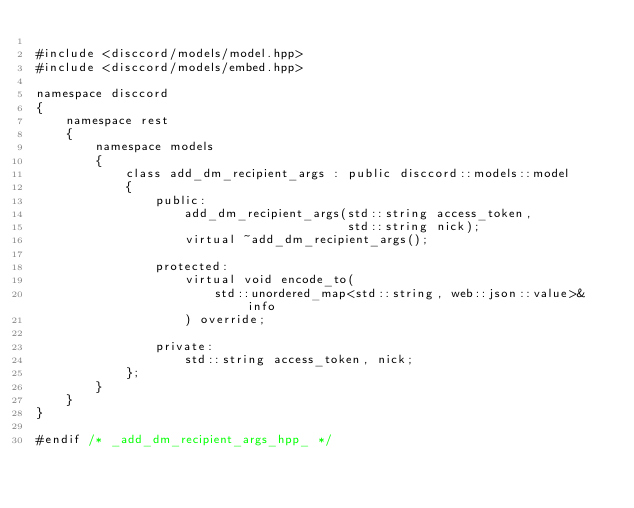<code> <loc_0><loc_0><loc_500><loc_500><_C++_>
#include <disccord/models/model.hpp>
#include <disccord/models/embed.hpp>

namespace disccord
{
    namespace rest
    {
        namespace models
        {
            class add_dm_recipient_args : public disccord::models::model
            {
                public:
                    add_dm_recipient_args(std::string access_token,
                                          std::string nick);
                    virtual ~add_dm_recipient_args();

                protected:
                    virtual void encode_to(
                        std::unordered_map<std::string, web::json::value>& info
                    ) override;

                private:
                    std::string access_token, nick;
            };
        }
    }
}

#endif /* _add_dm_recipient_args_hpp_ */
</code> 